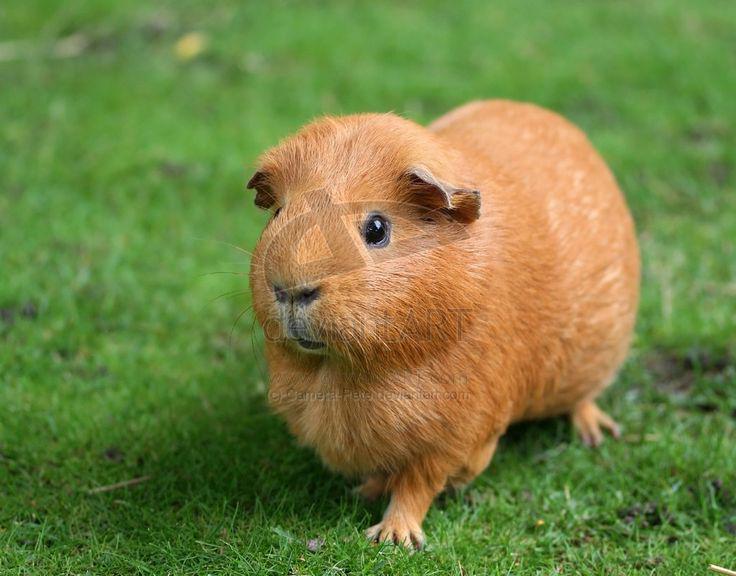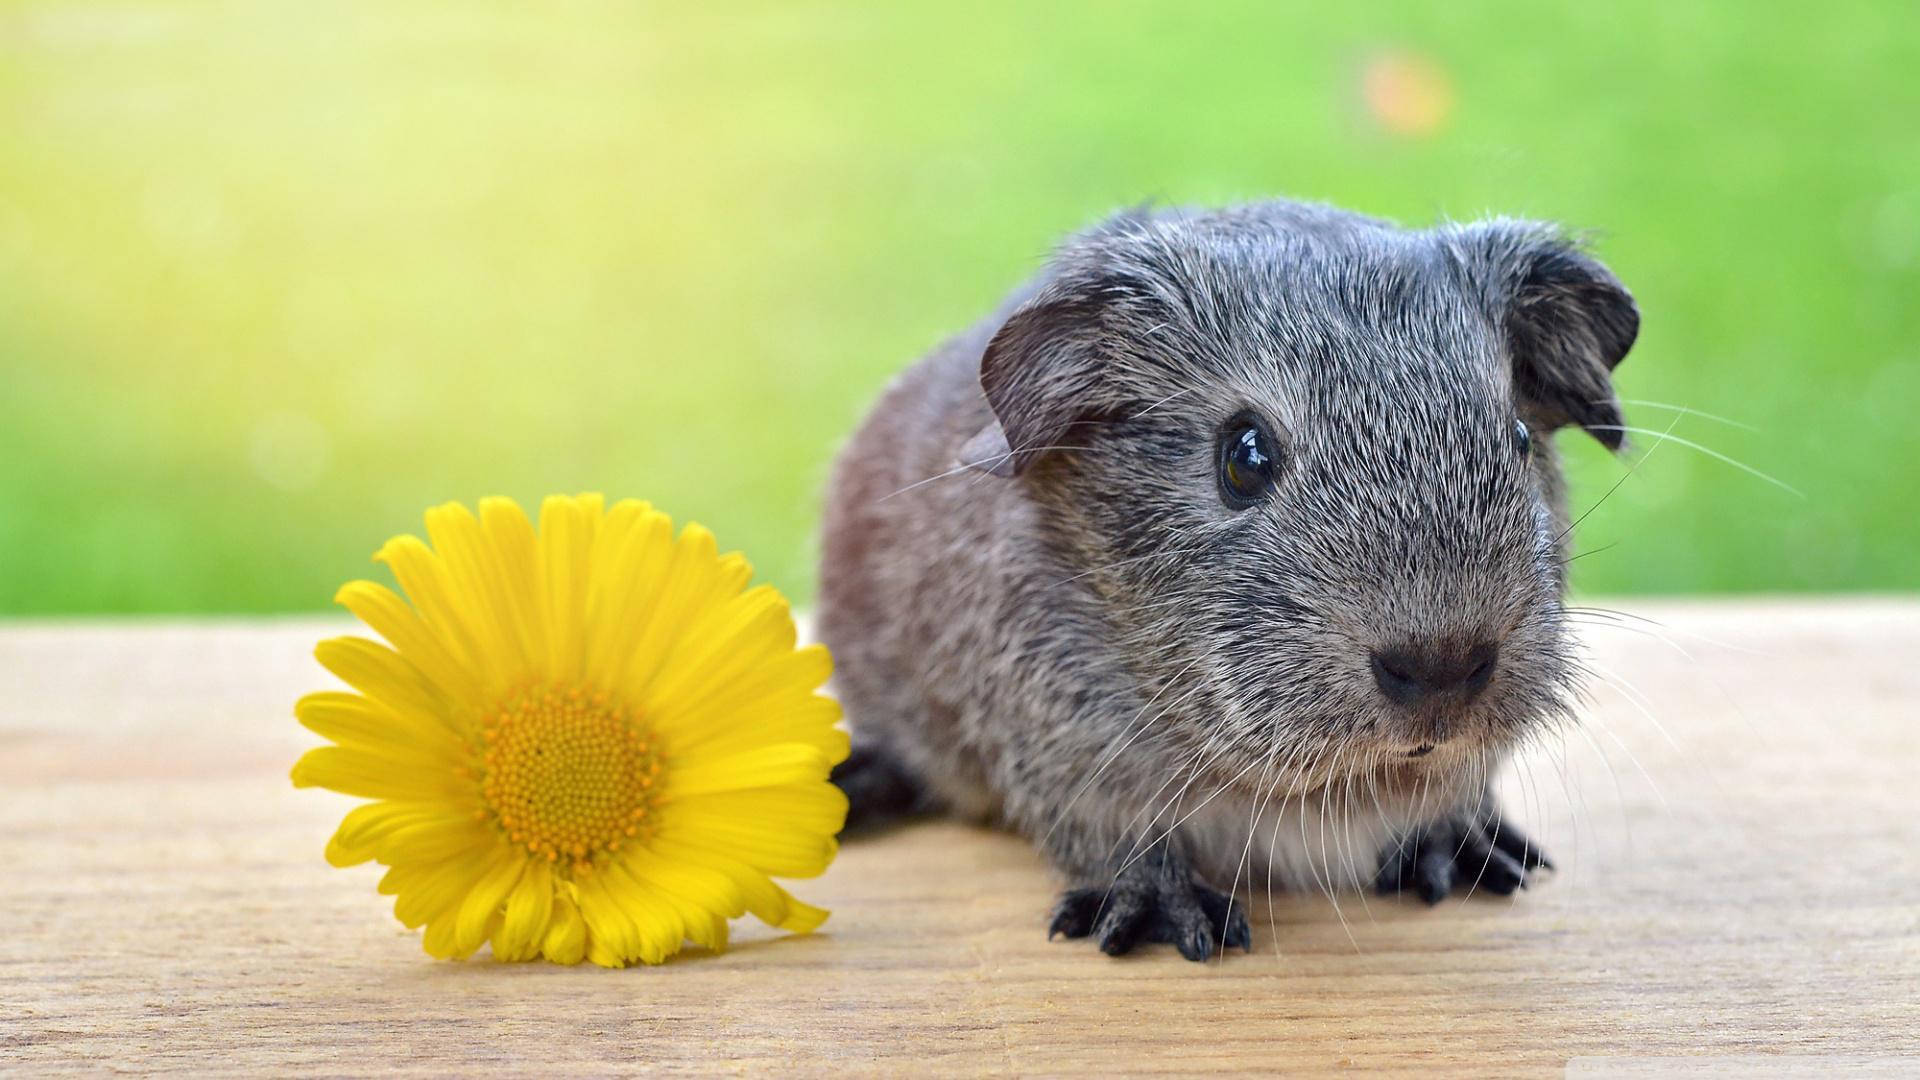The first image is the image on the left, the second image is the image on the right. Analyze the images presented: Is the assertion "At least one guinea pig has a brown face with a white stripe." valid? Answer yes or no. No. 